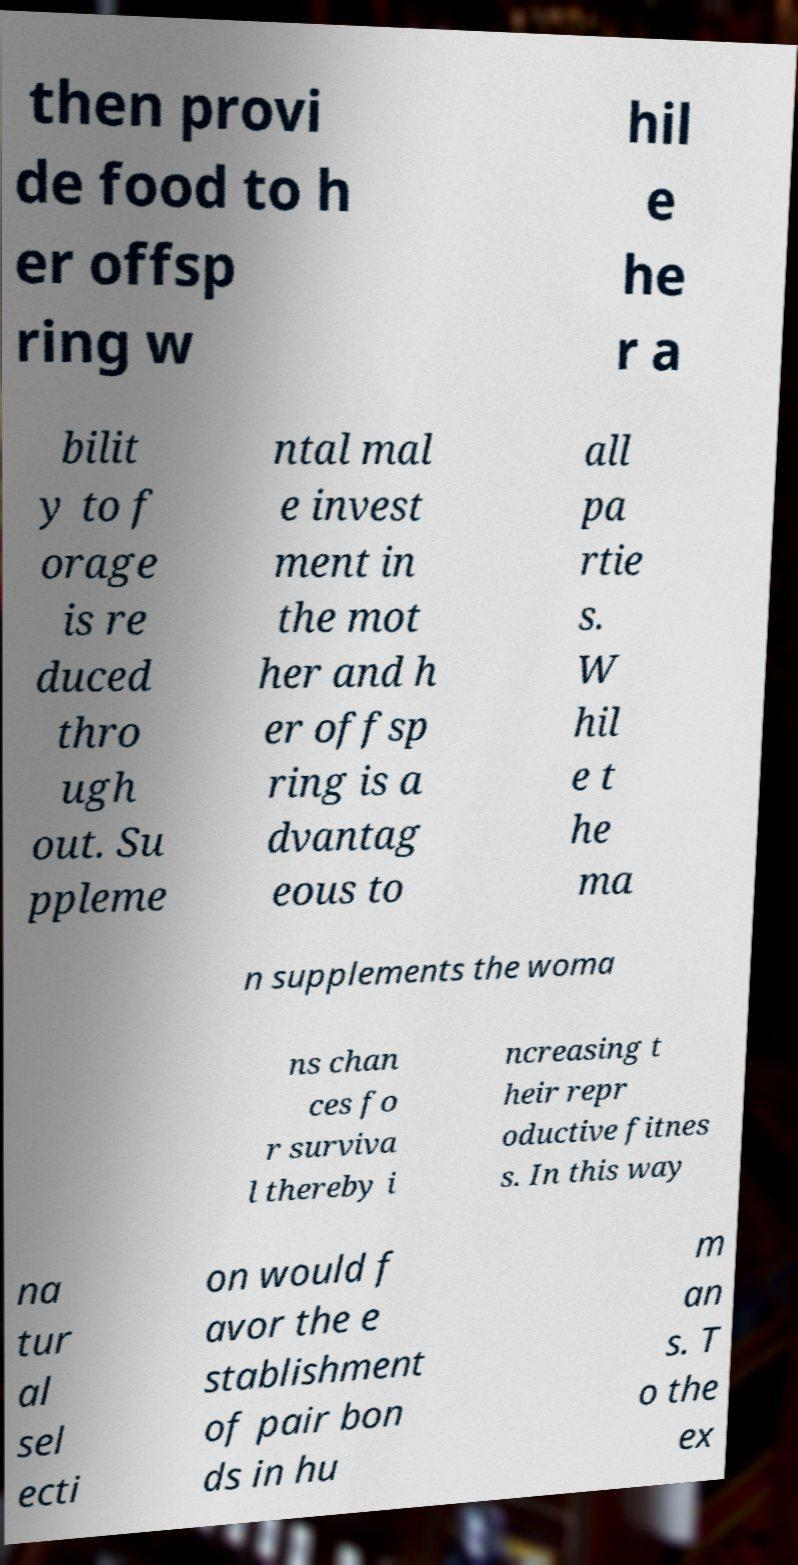Can you accurately transcribe the text from the provided image for me? then provi de food to h er offsp ring w hil e he r a bilit y to f orage is re duced thro ugh out. Su ppleme ntal mal e invest ment in the mot her and h er offsp ring is a dvantag eous to all pa rtie s. W hil e t he ma n supplements the woma ns chan ces fo r surviva l thereby i ncreasing t heir repr oductive fitnes s. In this way na tur al sel ecti on would f avor the e stablishment of pair bon ds in hu m an s. T o the ex 